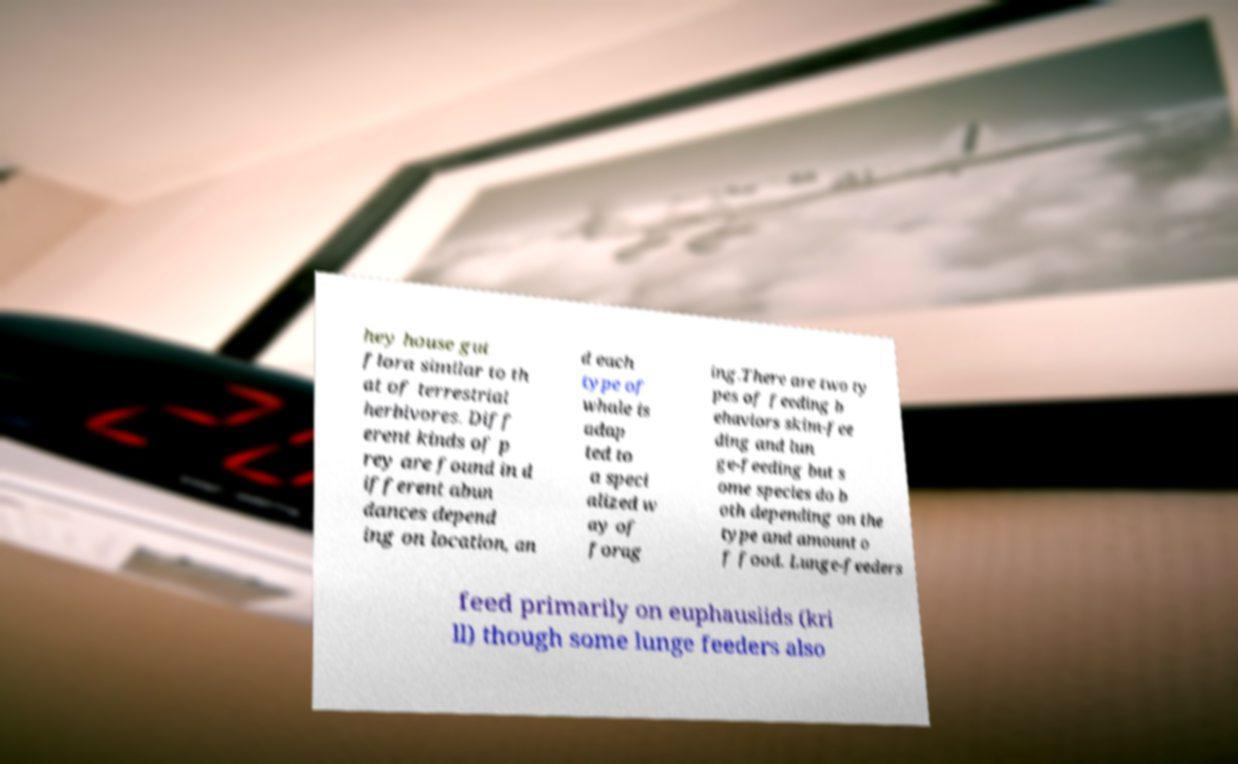Could you assist in decoding the text presented in this image and type it out clearly? hey house gut flora similar to th at of terrestrial herbivores. Diff erent kinds of p rey are found in d ifferent abun dances depend ing on location, an d each type of whale is adap ted to a speci alized w ay of forag ing.There are two ty pes of feeding b ehaviors skim-fee ding and lun ge-feeding but s ome species do b oth depending on the type and amount o f food. Lunge-feeders feed primarily on euphausiids (kri ll) though some lunge feeders also 